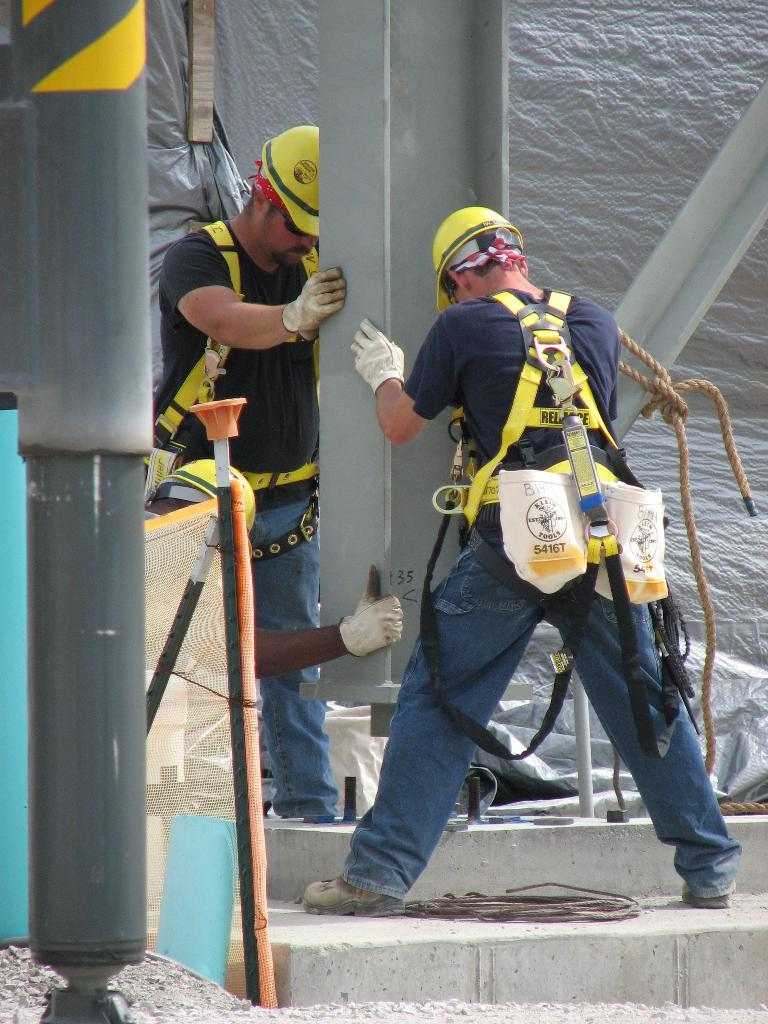What type of clothing are the men wearing on their upper bodies in the image? The men are wearing t-shirts in the image. What type of protective gear are the men wearing on their hands and heads? The men are wearing gloves and helmets in the image. What are the men holding in the image? The men are holding an iron object in the image. What type of wire can be seen in the image? There is a black wire in the image. What type of rope is present in the image? There is a rope in the image. What time is displayed on the clock in the image? There is no clock present in the image. How does the rope help the men breathe while they work? The image does not show any indication of the men needing assistance with breathing, and there is no rope connected to them for that purpose. 